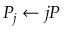Convert formula to latex. <formula><loc_0><loc_0><loc_500><loc_500>P _ { j } \leftarrow j P</formula> 